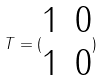<formula> <loc_0><loc_0><loc_500><loc_500>T = ( \begin{matrix} 1 & 0 \\ 1 & 0 \end{matrix} )</formula> 